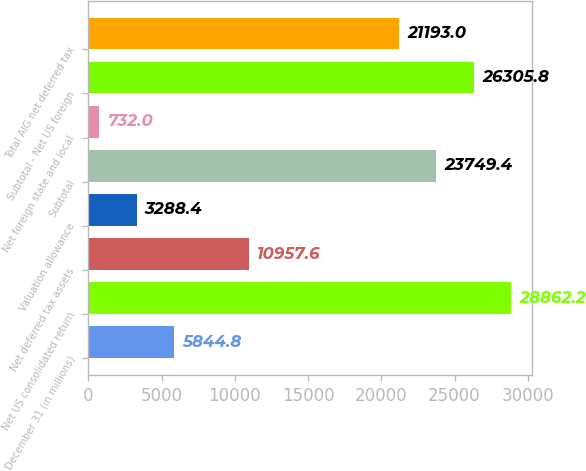Convert chart. <chart><loc_0><loc_0><loc_500><loc_500><bar_chart><fcel>December 31 (in millions)<fcel>Net US consolidated return<fcel>Net deferred tax assets<fcel>Valuation allowance<fcel>Subtotal<fcel>Net foreign state and local<fcel>Subtotal - Net US foreign<fcel>Total AIG net deferred tax<nl><fcel>5844.8<fcel>28862.2<fcel>10957.6<fcel>3288.4<fcel>23749.4<fcel>732<fcel>26305.8<fcel>21193<nl></chart> 